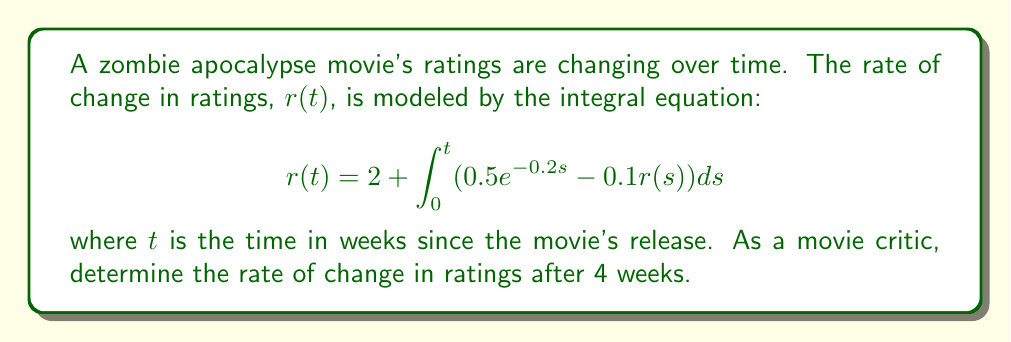Help me with this question. To solve this integral equation, we'll use the following steps:

1) First, we need to differentiate both sides of the equation with respect to $t$:

   $$\frac{d}{dt}r(t) = \frac{d}{dt}\left[2 + \int_0^t (0.5e^{-0.2s} - 0.1r(s)) ds\right]$$

2) Using the Fundamental Theorem of Calculus, we get:

   $$\frac{dr}{dt} = 0.5e^{-0.2t} - 0.1r(t)$$

3) This is now a first-order linear differential equation. We can solve it using the integrating factor method.

4) The integrating factor is $e^{\int 0.1 dt} = e^{0.1t}$.

5) Multiplying both sides by the integrating factor:

   $$e^{0.1t}\frac{dr}{dt} + 0.1e^{0.1t}r = 0.5e^{-0.1t}$$

6) The left side is now the derivative of $e^{0.1t}r$. So we can write:

   $$\frac{d}{dt}(e^{0.1t}r) = 0.5e^{-0.1t}$$

7) Integrating both sides:

   $$e^{0.1t}r = -5e^{-0.1t} + C$$

8) Solving for $r$:

   $$r(t) = -5e^{-0.2t} + Ce^{-0.1t}$$

9) Using the initial condition $r(0) = 2$ (from the original equation), we can find $C$:

   $$2 = -5 + C \implies C = 7$$

10) Therefore, the general solution is:

    $$r(t) = -5e^{-0.2t} + 7e^{-0.1t}$$

11) To find the rate of change after 4 weeks, we substitute $t = 4$:

    $$r(4) = -5e^{-0.8} + 7e^{-0.4}$$

12) Calculating this value:

    $$r(4) \approx -2.25 + 4.66 \approx 2.41$$
Answer: $2.41$ (units/week) 